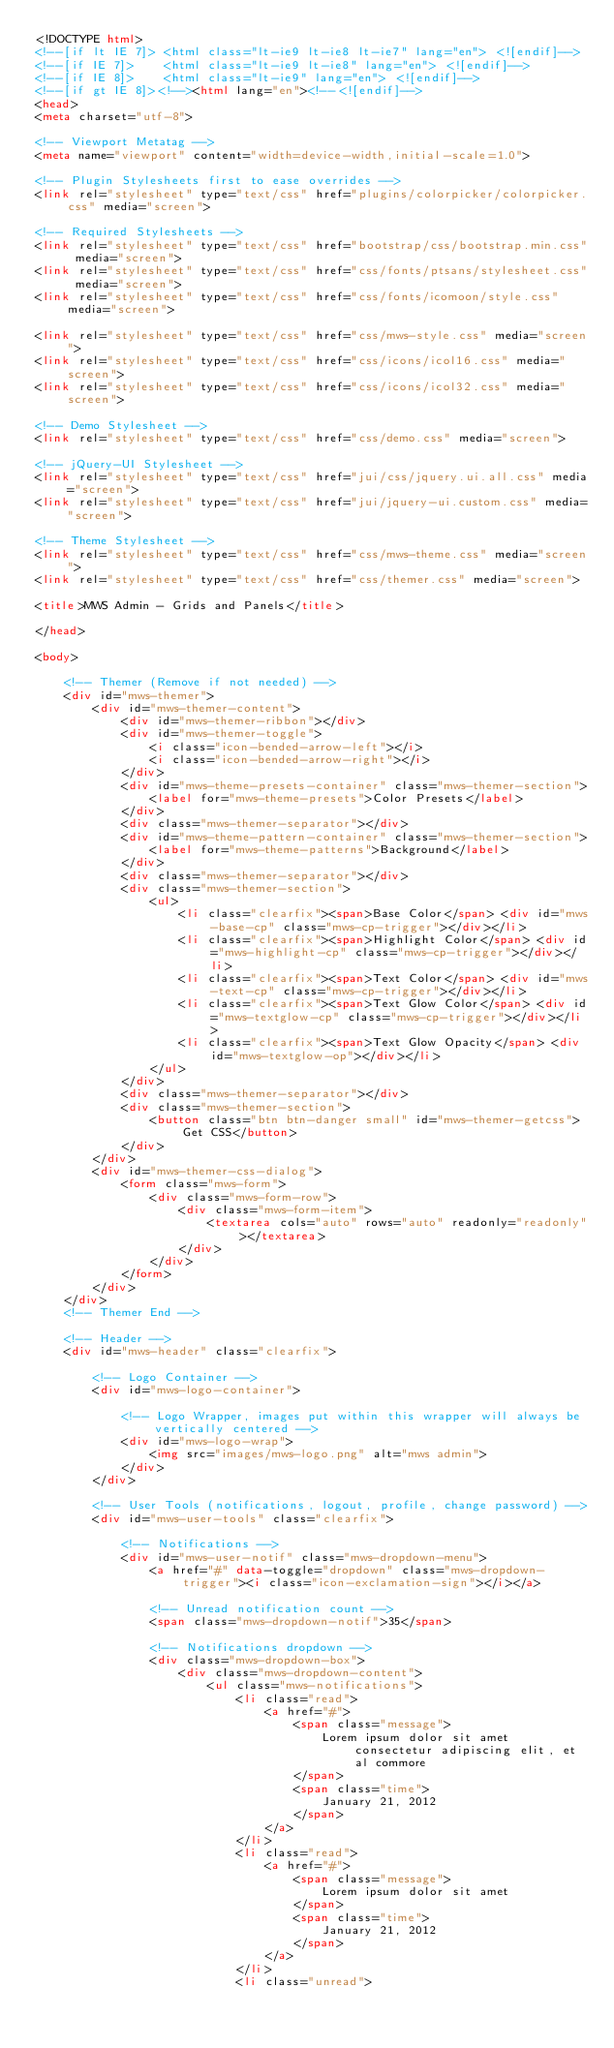Convert code to text. <code><loc_0><loc_0><loc_500><loc_500><_HTML_><!DOCTYPE html>
<!--[if lt IE 7]> <html class="lt-ie9 lt-ie8 lt-ie7" lang="en"> <![endif]-->
<!--[if IE 7]>    <html class="lt-ie9 lt-ie8" lang="en"> <![endif]-->
<!--[if IE 8]>    <html class="lt-ie9" lang="en"> <![endif]-->
<!--[if gt IE 8]><!--><html lang="en"><!--<![endif]-->
<head>
<meta charset="utf-8">

<!-- Viewport Metatag -->
<meta name="viewport" content="width=device-width,initial-scale=1.0">

<!-- Plugin Stylesheets first to ease overrides -->
<link rel="stylesheet" type="text/css" href="plugins/colorpicker/colorpicker.css" media="screen">

<!-- Required Stylesheets -->
<link rel="stylesheet" type="text/css" href="bootstrap/css/bootstrap.min.css" media="screen">
<link rel="stylesheet" type="text/css" href="css/fonts/ptsans/stylesheet.css" media="screen">
<link rel="stylesheet" type="text/css" href="css/fonts/icomoon/style.css" media="screen">

<link rel="stylesheet" type="text/css" href="css/mws-style.css" media="screen">
<link rel="stylesheet" type="text/css" href="css/icons/icol16.css" media="screen">
<link rel="stylesheet" type="text/css" href="css/icons/icol32.css" media="screen">

<!-- Demo Stylesheet -->
<link rel="stylesheet" type="text/css" href="css/demo.css" media="screen">

<!-- jQuery-UI Stylesheet -->
<link rel="stylesheet" type="text/css" href="jui/css/jquery.ui.all.css" media="screen">
<link rel="stylesheet" type="text/css" href="jui/jquery-ui.custom.css" media="screen">

<!-- Theme Stylesheet -->
<link rel="stylesheet" type="text/css" href="css/mws-theme.css" media="screen">
<link rel="stylesheet" type="text/css" href="css/themer.css" media="screen">

<title>MWS Admin - Grids and Panels</title>

</head>

<body>

	<!-- Themer (Remove if not needed) -->  
	<div id="mws-themer">
        <div id="mws-themer-content">
        	<div id="mws-themer-ribbon"></div>
            <div id="mws-themer-toggle">
                <i class="icon-bended-arrow-left"></i> 
                <i class="icon-bended-arrow-right"></i>
            </div>
        	<div id="mws-theme-presets-container" class="mws-themer-section">
	        	<label for="mws-theme-presets">Color Presets</label>
            </div>
            <div class="mws-themer-separator"></div>
        	<div id="mws-theme-pattern-container" class="mws-themer-section">
	        	<label for="mws-theme-patterns">Background</label>
            </div>
            <div class="mws-themer-separator"></div>
            <div class="mws-themer-section">
                <ul>
                    <li class="clearfix"><span>Base Color</span> <div id="mws-base-cp" class="mws-cp-trigger"></div></li>
                    <li class="clearfix"><span>Highlight Color</span> <div id="mws-highlight-cp" class="mws-cp-trigger"></div></li>
                    <li class="clearfix"><span>Text Color</span> <div id="mws-text-cp" class="mws-cp-trigger"></div></li>
                    <li class="clearfix"><span>Text Glow Color</span> <div id="mws-textglow-cp" class="mws-cp-trigger"></div></li>
                    <li class="clearfix"><span>Text Glow Opacity</span> <div id="mws-textglow-op"></div></li>
                </ul>
            </div>
            <div class="mws-themer-separator"></div>
            <div class="mws-themer-section">
	            <button class="btn btn-danger small" id="mws-themer-getcss">Get CSS</button>
            </div>
        </div>
        <div id="mws-themer-css-dialog">
        	<form class="mws-form">
            	<div class="mws-form-row">
		        	<div class="mws-form-item">
                    	<textarea cols="auto" rows="auto" readonly="readonly"></textarea>
                    </div>
                </div>
            </form>
        </div>
    </div>
    <!-- Themer End -->

	<!-- Header -->
	<div id="mws-header" class="clearfix">
    
    	<!-- Logo Container -->
    	<div id="mws-logo-container">
        
        	<!-- Logo Wrapper, images put within this wrapper will always be vertically centered -->
        	<div id="mws-logo-wrap">
            	<img src="images/mws-logo.png" alt="mws admin">
			</div>
        </div>
        
        <!-- User Tools (notifications, logout, profile, change password) -->
        <div id="mws-user-tools" class="clearfix">
        
        	<!-- Notifications -->
        	<div id="mws-user-notif" class="mws-dropdown-menu">
            	<a href="#" data-toggle="dropdown" class="mws-dropdown-trigger"><i class="icon-exclamation-sign"></i></a>
                
                <!-- Unread notification count -->
                <span class="mws-dropdown-notif">35</span>
                
                <!-- Notifications dropdown -->
                <div class="mws-dropdown-box">
                	<div class="mws-dropdown-content">
                        <ul class="mws-notifications">
                        	<li class="read">
                            	<a href="#">
                                    <span class="message">
                                        Lorem ipsum dolor sit amet consectetur adipiscing elit, et al commore
                                    </span>
                                    <span class="time">
                                        January 21, 2012
                                    </span>
                                </a>
                            </li>
                        	<li class="read">
                            	<a href="#">
                                    <span class="message">
                                        Lorem ipsum dolor sit amet
                                    </span>
                                    <span class="time">
                                        January 21, 2012
                                    </span>
                                </a>
                            </li>
                        	<li class="unread"></code> 